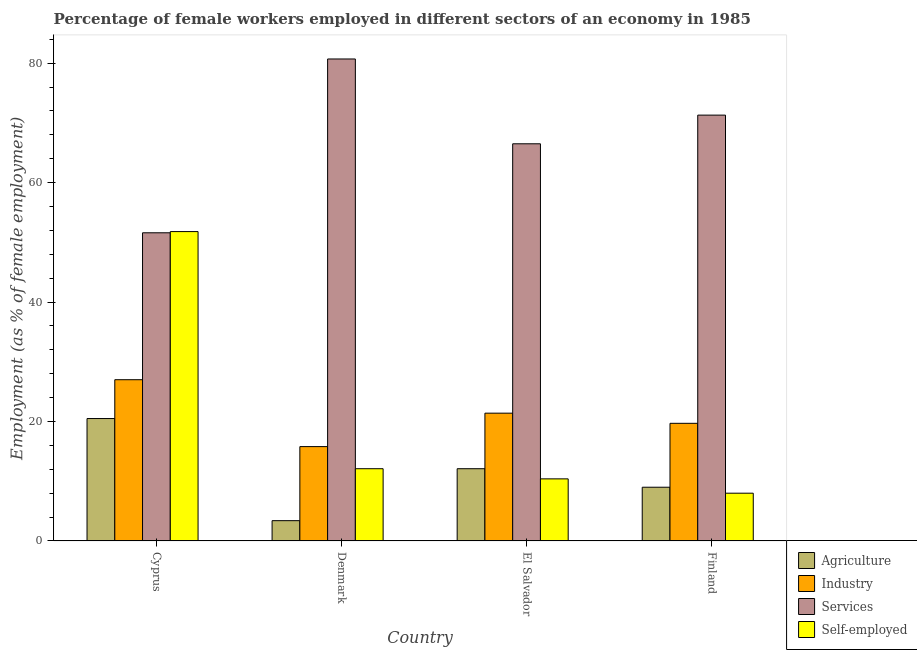Are the number of bars on each tick of the X-axis equal?
Offer a very short reply. Yes. How many bars are there on the 3rd tick from the left?
Give a very brief answer. 4. How many bars are there on the 1st tick from the right?
Your answer should be compact. 4. What is the percentage of female workers in services in Cyprus?
Your response must be concise. 51.6. Across all countries, what is the maximum percentage of self employed female workers?
Ensure brevity in your answer.  51.8. Across all countries, what is the minimum percentage of female workers in services?
Provide a succinct answer. 51.6. In which country was the percentage of female workers in services maximum?
Make the answer very short. Denmark. In which country was the percentage of female workers in agriculture minimum?
Keep it short and to the point. Denmark. What is the total percentage of self employed female workers in the graph?
Offer a terse response. 82.3. What is the difference between the percentage of self employed female workers in Denmark and that in Finland?
Offer a terse response. 4.1. What is the difference between the percentage of female workers in industry in Cyprus and the percentage of female workers in services in Finland?
Provide a short and direct response. -44.3. What is the average percentage of self employed female workers per country?
Your answer should be very brief. 20.57. What is the difference between the percentage of female workers in industry and percentage of self employed female workers in El Salvador?
Offer a terse response. 11. What is the ratio of the percentage of female workers in agriculture in Denmark to that in El Salvador?
Provide a short and direct response. 0.28. Is the percentage of female workers in services in Cyprus less than that in El Salvador?
Give a very brief answer. Yes. Is the difference between the percentage of female workers in industry in Denmark and Finland greater than the difference between the percentage of female workers in agriculture in Denmark and Finland?
Provide a succinct answer. Yes. What is the difference between the highest and the second highest percentage of self employed female workers?
Your response must be concise. 39.7. What is the difference between the highest and the lowest percentage of self employed female workers?
Make the answer very short. 43.8. In how many countries, is the percentage of self employed female workers greater than the average percentage of self employed female workers taken over all countries?
Offer a terse response. 1. Is it the case that in every country, the sum of the percentage of self employed female workers and percentage of female workers in services is greater than the sum of percentage of female workers in agriculture and percentage of female workers in industry?
Your answer should be compact. Yes. What does the 3rd bar from the left in El Salvador represents?
Provide a short and direct response. Services. What does the 2nd bar from the right in Denmark represents?
Offer a very short reply. Services. How many bars are there?
Ensure brevity in your answer.  16. Are all the bars in the graph horizontal?
Offer a very short reply. No. Does the graph contain any zero values?
Your response must be concise. No. Where does the legend appear in the graph?
Your answer should be very brief. Bottom right. How are the legend labels stacked?
Offer a very short reply. Vertical. What is the title of the graph?
Your answer should be compact. Percentage of female workers employed in different sectors of an economy in 1985. What is the label or title of the Y-axis?
Offer a very short reply. Employment (as % of female employment). What is the Employment (as % of female employment) of Agriculture in Cyprus?
Provide a succinct answer. 20.5. What is the Employment (as % of female employment) of Industry in Cyprus?
Your response must be concise. 27. What is the Employment (as % of female employment) in Services in Cyprus?
Give a very brief answer. 51.6. What is the Employment (as % of female employment) of Self-employed in Cyprus?
Your response must be concise. 51.8. What is the Employment (as % of female employment) of Agriculture in Denmark?
Give a very brief answer. 3.4. What is the Employment (as % of female employment) in Industry in Denmark?
Your answer should be very brief. 15.8. What is the Employment (as % of female employment) of Services in Denmark?
Give a very brief answer. 80.7. What is the Employment (as % of female employment) in Self-employed in Denmark?
Ensure brevity in your answer.  12.1. What is the Employment (as % of female employment) in Agriculture in El Salvador?
Ensure brevity in your answer.  12.1. What is the Employment (as % of female employment) in Industry in El Salvador?
Your answer should be compact. 21.4. What is the Employment (as % of female employment) in Services in El Salvador?
Keep it short and to the point. 66.5. What is the Employment (as % of female employment) in Self-employed in El Salvador?
Offer a very short reply. 10.4. What is the Employment (as % of female employment) of Agriculture in Finland?
Offer a terse response. 9. What is the Employment (as % of female employment) of Industry in Finland?
Offer a terse response. 19.7. What is the Employment (as % of female employment) in Services in Finland?
Offer a very short reply. 71.3. What is the Employment (as % of female employment) of Self-employed in Finland?
Ensure brevity in your answer.  8. Across all countries, what is the maximum Employment (as % of female employment) of Services?
Your answer should be compact. 80.7. Across all countries, what is the maximum Employment (as % of female employment) in Self-employed?
Make the answer very short. 51.8. Across all countries, what is the minimum Employment (as % of female employment) in Agriculture?
Your response must be concise. 3.4. Across all countries, what is the minimum Employment (as % of female employment) in Industry?
Provide a short and direct response. 15.8. Across all countries, what is the minimum Employment (as % of female employment) in Services?
Your answer should be very brief. 51.6. Across all countries, what is the minimum Employment (as % of female employment) in Self-employed?
Keep it short and to the point. 8. What is the total Employment (as % of female employment) of Industry in the graph?
Offer a terse response. 83.9. What is the total Employment (as % of female employment) of Services in the graph?
Make the answer very short. 270.1. What is the total Employment (as % of female employment) in Self-employed in the graph?
Provide a short and direct response. 82.3. What is the difference between the Employment (as % of female employment) of Agriculture in Cyprus and that in Denmark?
Keep it short and to the point. 17.1. What is the difference between the Employment (as % of female employment) of Industry in Cyprus and that in Denmark?
Give a very brief answer. 11.2. What is the difference between the Employment (as % of female employment) of Services in Cyprus and that in Denmark?
Provide a short and direct response. -29.1. What is the difference between the Employment (as % of female employment) in Self-employed in Cyprus and that in Denmark?
Offer a very short reply. 39.7. What is the difference between the Employment (as % of female employment) of Agriculture in Cyprus and that in El Salvador?
Provide a short and direct response. 8.4. What is the difference between the Employment (as % of female employment) of Industry in Cyprus and that in El Salvador?
Offer a very short reply. 5.6. What is the difference between the Employment (as % of female employment) of Services in Cyprus and that in El Salvador?
Give a very brief answer. -14.9. What is the difference between the Employment (as % of female employment) of Self-employed in Cyprus and that in El Salvador?
Provide a short and direct response. 41.4. What is the difference between the Employment (as % of female employment) of Industry in Cyprus and that in Finland?
Your response must be concise. 7.3. What is the difference between the Employment (as % of female employment) of Services in Cyprus and that in Finland?
Offer a terse response. -19.7. What is the difference between the Employment (as % of female employment) in Self-employed in Cyprus and that in Finland?
Provide a succinct answer. 43.8. What is the difference between the Employment (as % of female employment) in Agriculture in Denmark and that in El Salvador?
Provide a succinct answer. -8.7. What is the difference between the Employment (as % of female employment) of Self-employed in Denmark and that in El Salvador?
Make the answer very short. 1.7. What is the difference between the Employment (as % of female employment) of Industry in Denmark and that in Finland?
Make the answer very short. -3.9. What is the difference between the Employment (as % of female employment) of Services in El Salvador and that in Finland?
Offer a terse response. -4.8. What is the difference between the Employment (as % of female employment) of Self-employed in El Salvador and that in Finland?
Keep it short and to the point. 2.4. What is the difference between the Employment (as % of female employment) in Agriculture in Cyprus and the Employment (as % of female employment) in Industry in Denmark?
Keep it short and to the point. 4.7. What is the difference between the Employment (as % of female employment) of Agriculture in Cyprus and the Employment (as % of female employment) of Services in Denmark?
Provide a short and direct response. -60.2. What is the difference between the Employment (as % of female employment) in Agriculture in Cyprus and the Employment (as % of female employment) in Self-employed in Denmark?
Ensure brevity in your answer.  8.4. What is the difference between the Employment (as % of female employment) of Industry in Cyprus and the Employment (as % of female employment) of Services in Denmark?
Give a very brief answer. -53.7. What is the difference between the Employment (as % of female employment) of Industry in Cyprus and the Employment (as % of female employment) of Self-employed in Denmark?
Offer a terse response. 14.9. What is the difference between the Employment (as % of female employment) in Services in Cyprus and the Employment (as % of female employment) in Self-employed in Denmark?
Offer a very short reply. 39.5. What is the difference between the Employment (as % of female employment) in Agriculture in Cyprus and the Employment (as % of female employment) in Services in El Salvador?
Ensure brevity in your answer.  -46. What is the difference between the Employment (as % of female employment) of Agriculture in Cyprus and the Employment (as % of female employment) of Self-employed in El Salvador?
Your response must be concise. 10.1. What is the difference between the Employment (as % of female employment) of Industry in Cyprus and the Employment (as % of female employment) of Services in El Salvador?
Your response must be concise. -39.5. What is the difference between the Employment (as % of female employment) in Industry in Cyprus and the Employment (as % of female employment) in Self-employed in El Salvador?
Provide a succinct answer. 16.6. What is the difference between the Employment (as % of female employment) in Services in Cyprus and the Employment (as % of female employment) in Self-employed in El Salvador?
Provide a short and direct response. 41.2. What is the difference between the Employment (as % of female employment) in Agriculture in Cyprus and the Employment (as % of female employment) in Industry in Finland?
Provide a succinct answer. 0.8. What is the difference between the Employment (as % of female employment) in Agriculture in Cyprus and the Employment (as % of female employment) in Services in Finland?
Offer a very short reply. -50.8. What is the difference between the Employment (as % of female employment) of Agriculture in Cyprus and the Employment (as % of female employment) of Self-employed in Finland?
Offer a very short reply. 12.5. What is the difference between the Employment (as % of female employment) of Industry in Cyprus and the Employment (as % of female employment) of Services in Finland?
Your answer should be very brief. -44.3. What is the difference between the Employment (as % of female employment) in Services in Cyprus and the Employment (as % of female employment) in Self-employed in Finland?
Your answer should be very brief. 43.6. What is the difference between the Employment (as % of female employment) of Agriculture in Denmark and the Employment (as % of female employment) of Services in El Salvador?
Provide a succinct answer. -63.1. What is the difference between the Employment (as % of female employment) in Agriculture in Denmark and the Employment (as % of female employment) in Self-employed in El Salvador?
Offer a terse response. -7. What is the difference between the Employment (as % of female employment) in Industry in Denmark and the Employment (as % of female employment) in Services in El Salvador?
Provide a succinct answer. -50.7. What is the difference between the Employment (as % of female employment) of Services in Denmark and the Employment (as % of female employment) of Self-employed in El Salvador?
Your response must be concise. 70.3. What is the difference between the Employment (as % of female employment) of Agriculture in Denmark and the Employment (as % of female employment) of Industry in Finland?
Your answer should be compact. -16.3. What is the difference between the Employment (as % of female employment) in Agriculture in Denmark and the Employment (as % of female employment) in Services in Finland?
Ensure brevity in your answer.  -67.9. What is the difference between the Employment (as % of female employment) of Agriculture in Denmark and the Employment (as % of female employment) of Self-employed in Finland?
Make the answer very short. -4.6. What is the difference between the Employment (as % of female employment) of Industry in Denmark and the Employment (as % of female employment) of Services in Finland?
Keep it short and to the point. -55.5. What is the difference between the Employment (as % of female employment) of Industry in Denmark and the Employment (as % of female employment) of Self-employed in Finland?
Make the answer very short. 7.8. What is the difference between the Employment (as % of female employment) of Services in Denmark and the Employment (as % of female employment) of Self-employed in Finland?
Keep it short and to the point. 72.7. What is the difference between the Employment (as % of female employment) in Agriculture in El Salvador and the Employment (as % of female employment) in Industry in Finland?
Ensure brevity in your answer.  -7.6. What is the difference between the Employment (as % of female employment) of Agriculture in El Salvador and the Employment (as % of female employment) of Services in Finland?
Keep it short and to the point. -59.2. What is the difference between the Employment (as % of female employment) of Agriculture in El Salvador and the Employment (as % of female employment) of Self-employed in Finland?
Your response must be concise. 4.1. What is the difference between the Employment (as % of female employment) of Industry in El Salvador and the Employment (as % of female employment) of Services in Finland?
Your answer should be very brief. -49.9. What is the difference between the Employment (as % of female employment) of Services in El Salvador and the Employment (as % of female employment) of Self-employed in Finland?
Give a very brief answer. 58.5. What is the average Employment (as % of female employment) of Agriculture per country?
Give a very brief answer. 11.25. What is the average Employment (as % of female employment) of Industry per country?
Provide a succinct answer. 20.98. What is the average Employment (as % of female employment) of Services per country?
Offer a terse response. 67.53. What is the average Employment (as % of female employment) of Self-employed per country?
Make the answer very short. 20.57. What is the difference between the Employment (as % of female employment) of Agriculture and Employment (as % of female employment) of Services in Cyprus?
Make the answer very short. -31.1. What is the difference between the Employment (as % of female employment) in Agriculture and Employment (as % of female employment) in Self-employed in Cyprus?
Give a very brief answer. -31.3. What is the difference between the Employment (as % of female employment) in Industry and Employment (as % of female employment) in Services in Cyprus?
Your response must be concise. -24.6. What is the difference between the Employment (as % of female employment) in Industry and Employment (as % of female employment) in Self-employed in Cyprus?
Your response must be concise. -24.8. What is the difference between the Employment (as % of female employment) of Services and Employment (as % of female employment) of Self-employed in Cyprus?
Your answer should be very brief. -0.2. What is the difference between the Employment (as % of female employment) of Agriculture and Employment (as % of female employment) of Industry in Denmark?
Your answer should be very brief. -12.4. What is the difference between the Employment (as % of female employment) of Agriculture and Employment (as % of female employment) of Services in Denmark?
Provide a short and direct response. -77.3. What is the difference between the Employment (as % of female employment) of Agriculture and Employment (as % of female employment) of Self-employed in Denmark?
Your answer should be compact. -8.7. What is the difference between the Employment (as % of female employment) in Industry and Employment (as % of female employment) in Services in Denmark?
Offer a terse response. -64.9. What is the difference between the Employment (as % of female employment) in Services and Employment (as % of female employment) in Self-employed in Denmark?
Your answer should be very brief. 68.6. What is the difference between the Employment (as % of female employment) in Agriculture and Employment (as % of female employment) in Industry in El Salvador?
Provide a short and direct response. -9.3. What is the difference between the Employment (as % of female employment) in Agriculture and Employment (as % of female employment) in Services in El Salvador?
Make the answer very short. -54.4. What is the difference between the Employment (as % of female employment) of Industry and Employment (as % of female employment) of Services in El Salvador?
Ensure brevity in your answer.  -45.1. What is the difference between the Employment (as % of female employment) of Industry and Employment (as % of female employment) of Self-employed in El Salvador?
Your answer should be very brief. 11. What is the difference between the Employment (as % of female employment) in Services and Employment (as % of female employment) in Self-employed in El Salvador?
Ensure brevity in your answer.  56.1. What is the difference between the Employment (as % of female employment) of Agriculture and Employment (as % of female employment) of Industry in Finland?
Keep it short and to the point. -10.7. What is the difference between the Employment (as % of female employment) in Agriculture and Employment (as % of female employment) in Services in Finland?
Offer a very short reply. -62.3. What is the difference between the Employment (as % of female employment) of Agriculture and Employment (as % of female employment) of Self-employed in Finland?
Offer a very short reply. 1. What is the difference between the Employment (as % of female employment) in Industry and Employment (as % of female employment) in Services in Finland?
Your response must be concise. -51.6. What is the difference between the Employment (as % of female employment) in Services and Employment (as % of female employment) in Self-employed in Finland?
Ensure brevity in your answer.  63.3. What is the ratio of the Employment (as % of female employment) in Agriculture in Cyprus to that in Denmark?
Your response must be concise. 6.03. What is the ratio of the Employment (as % of female employment) of Industry in Cyprus to that in Denmark?
Provide a succinct answer. 1.71. What is the ratio of the Employment (as % of female employment) of Services in Cyprus to that in Denmark?
Your answer should be very brief. 0.64. What is the ratio of the Employment (as % of female employment) in Self-employed in Cyprus to that in Denmark?
Your answer should be compact. 4.28. What is the ratio of the Employment (as % of female employment) of Agriculture in Cyprus to that in El Salvador?
Ensure brevity in your answer.  1.69. What is the ratio of the Employment (as % of female employment) in Industry in Cyprus to that in El Salvador?
Your answer should be very brief. 1.26. What is the ratio of the Employment (as % of female employment) of Services in Cyprus to that in El Salvador?
Your answer should be very brief. 0.78. What is the ratio of the Employment (as % of female employment) in Self-employed in Cyprus to that in El Salvador?
Make the answer very short. 4.98. What is the ratio of the Employment (as % of female employment) in Agriculture in Cyprus to that in Finland?
Your answer should be compact. 2.28. What is the ratio of the Employment (as % of female employment) of Industry in Cyprus to that in Finland?
Provide a succinct answer. 1.37. What is the ratio of the Employment (as % of female employment) in Services in Cyprus to that in Finland?
Give a very brief answer. 0.72. What is the ratio of the Employment (as % of female employment) in Self-employed in Cyprus to that in Finland?
Provide a succinct answer. 6.47. What is the ratio of the Employment (as % of female employment) of Agriculture in Denmark to that in El Salvador?
Your response must be concise. 0.28. What is the ratio of the Employment (as % of female employment) of Industry in Denmark to that in El Salvador?
Ensure brevity in your answer.  0.74. What is the ratio of the Employment (as % of female employment) in Services in Denmark to that in El Salvador?
Your answer should be compact. 1.21. What is the ratio of the Employment (as % of female employment) in Self-employed in Denmark to that in El Salvador?
Offer a very short reply. 1.16. What is the ratio of the Employment (as % of female employment) of Agriculture in Denmark to that in Finland?
Give a very brief answer. 0.38. What is the ratio of the Employment (as % of female employment) of Industry in Denmark to that in Finland?
Your answer should be compact. 0.8. What is the ratio of the Employment (as % of female employment) in Services in Denmark to that in Finland?
Offer a very short reply. 1.13. What is the ratio of the Employment (as % of female employment) in Self-employed in Denmark to that in Finland?
Your answer should be compact. 1.51. What is the ratio of the Employment (as % of female employment) in Agriculture in El Salvador to that in Finland?
Give a very brief answer. 1.34. What is the ratio of the Employment (as % of female employment) in Industry in El Salvador to that in Finland?
Make the answer very short. 1.09. What is the ratio of the Employment (as % of female employment) of Services in El Salvador to that in Finland?
Keep it short and to the point. 0.93. What is the difference between the highest and the second highest Employment (as % of female employment) of Industry?
Your answer should be very brief. 5.6. What is the difference between the highest and the second highest Employment (as % of female employment) of Self-employed?
Ensure brevity in your answer.  39.7. What is the difference between the highest and the lowest Employment (as % of female employment) in Agriculture?
Provide a succinct answer. 17.1. What is the difference between the highest and the lowest Employment (as % of female employment) in Services?
Offer a terse response. 29.1. What is the difference between the highest and the lowest Employment (as % of female employment) of Self-employed?
Your answer should be compact. 43.8. 